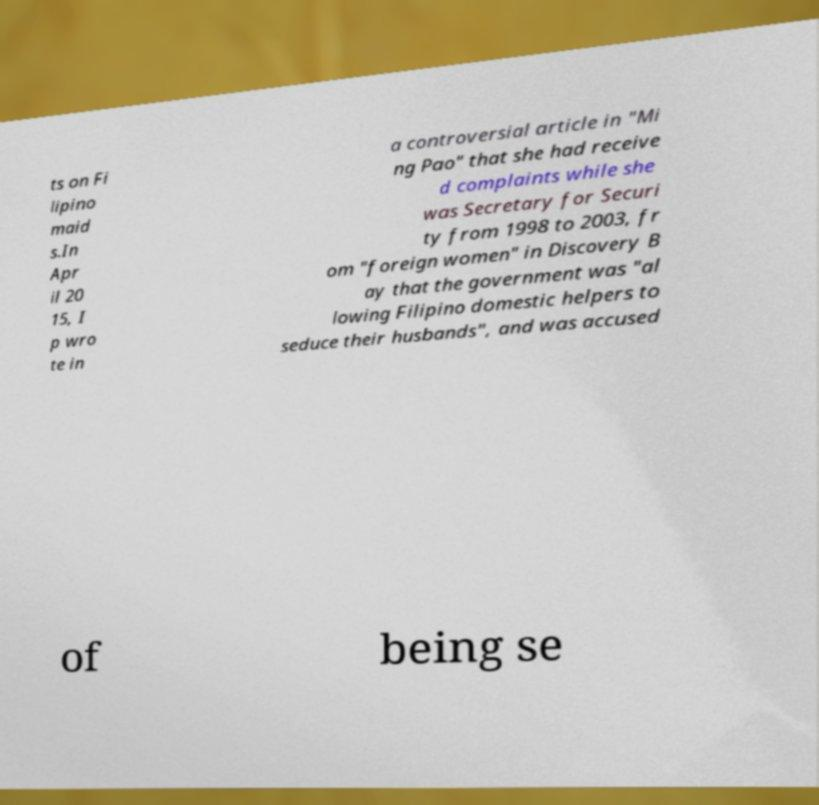Could you assist in decoding the text presented in this image and type it out clearly? ts on Fi lipino maid s.In Apr il 20 15, I p wro te in a controversial article in "Mi ng Pao" that she had receive d complaints while she was Secretary for Securi ty from 1998 to 2003, fr om "foreign women" in Discovery B ay that the government was "al lowing Filipino domestic helpers to seduce their husbands", and was accused of being se 